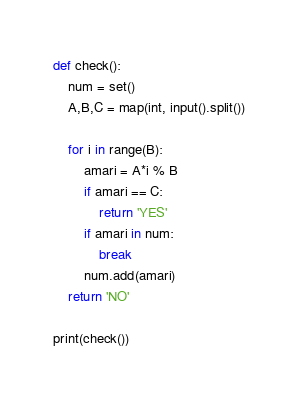<code> <loc_0><loc_0><loc_500><loc_500><_Python_>def check():
    num = set()
    A,B,C = map(int, input().split())
    
    for i in range(B):
        amari = A*i % B
        if amari == C:
            return 'YES'
        if amari in num:
            break
        num.add(amari)
    return 'NO'
  
print(check())</code> 